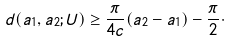Convert formula to latex. <formula><loc_0><loc_0><loc_500><loc_500>d ( a _ { 1 } , a _ { 2 } ; U ) \geq \frac { \pi } { 4 c } ( a _ { 2 } - a _ { 1 } ) - \frac { \pi } { 2 } \cdot</formula> 